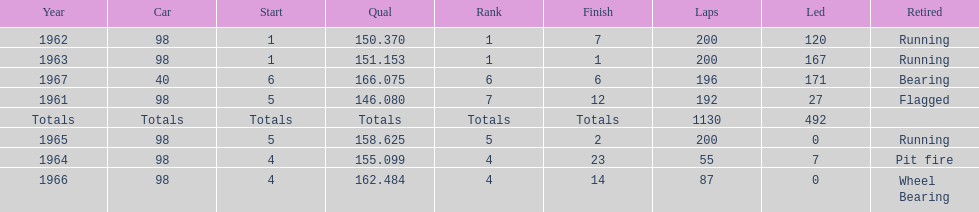What is the most common cause for a retired car? Running. 